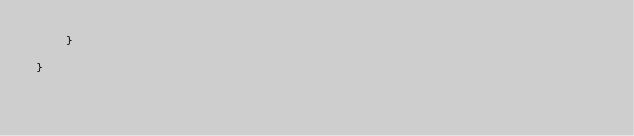Convert code to text. <code><loc_0><loc_0><loc_500><loc_500><_Kotlin_>    }

}
</code> 